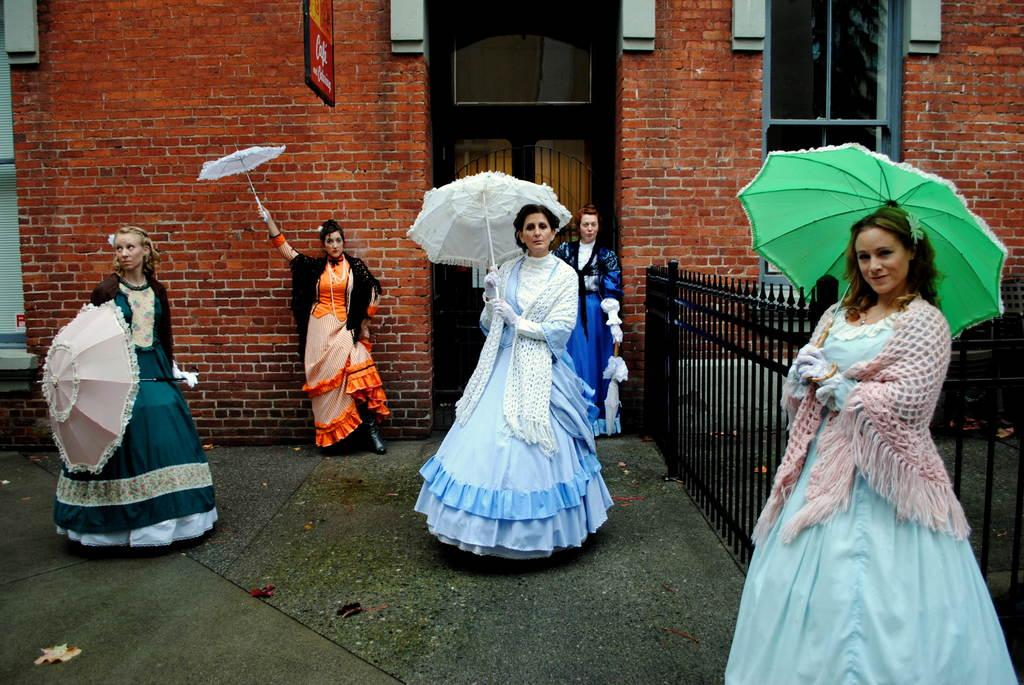Who is present in the image? There are women in the image. What are the women doing in the image? The women are standing and holding umbrellas. What can be seen in the background of the image? There is a building in the background of the image. What type of iron is being used by the women in the image? There is no iron present in the image; the women are holding umbrellas. 